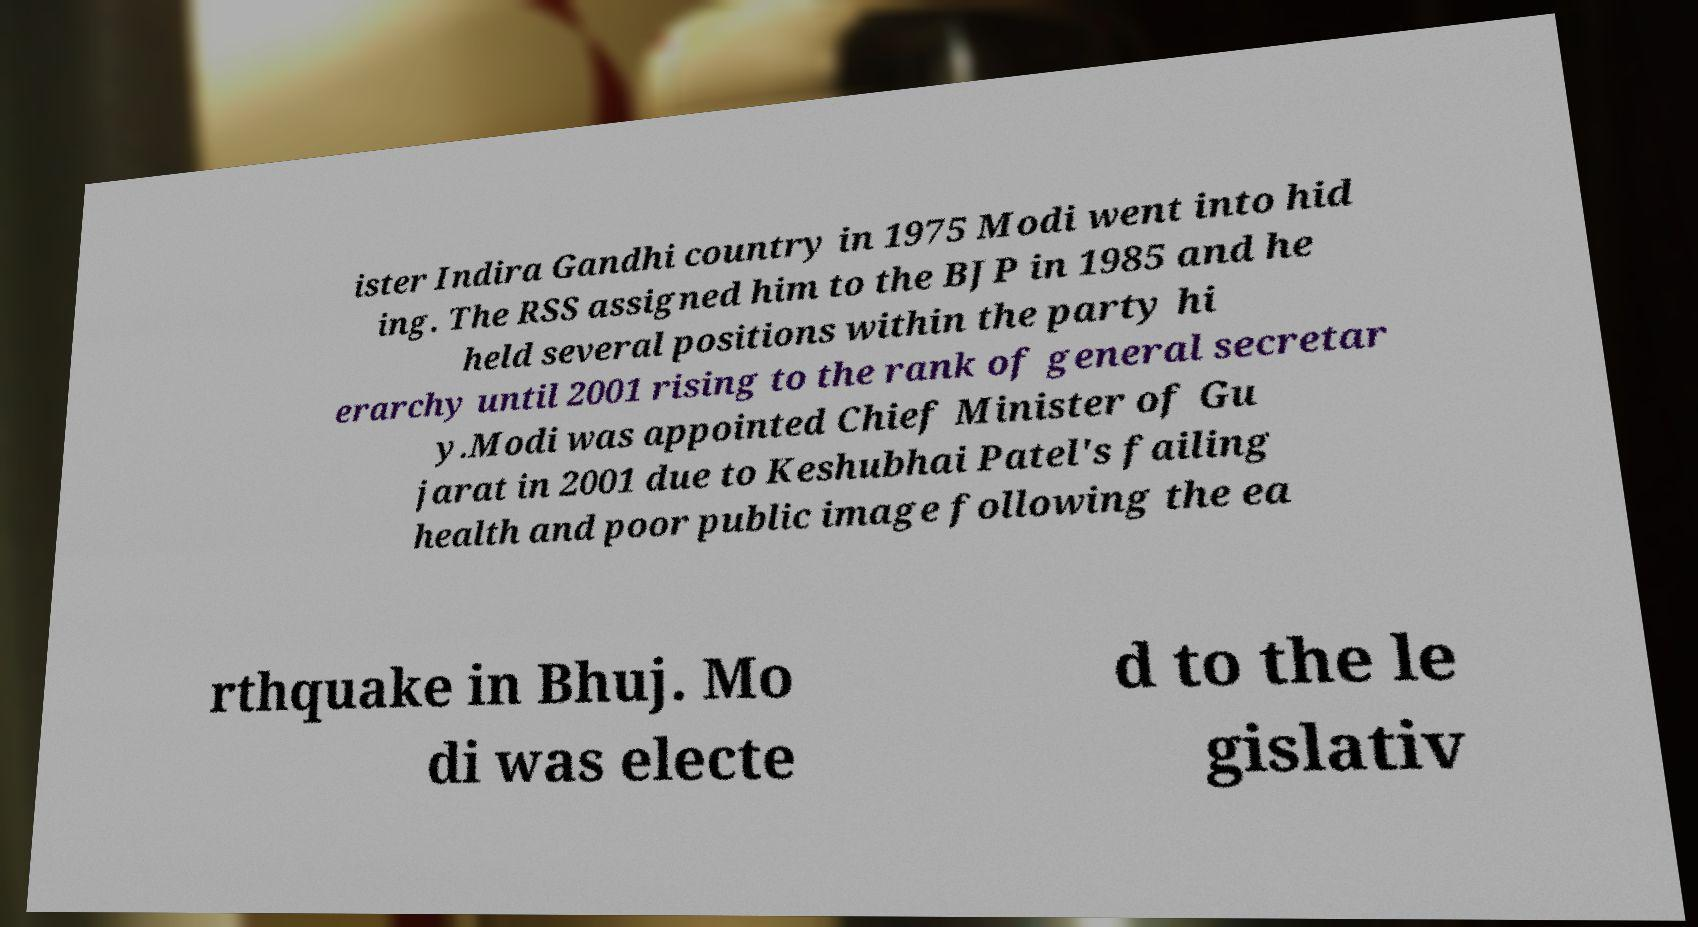Could you extract and type out the text from this image? ister Indira Gandhi country in 1975 Modi went into hid ing. The RSS assigned him to the BJP in 1985 and he held several positions within the party hi erarchy until 2001 rising to the rank of general secretar y.Modi was appointed Chief Minister of Gu jarat in 2001 due to Keshubhai Patel's failing health and poor public image following the ea rthquake in Bhuj. Mo di was electe d to the le gislativ 